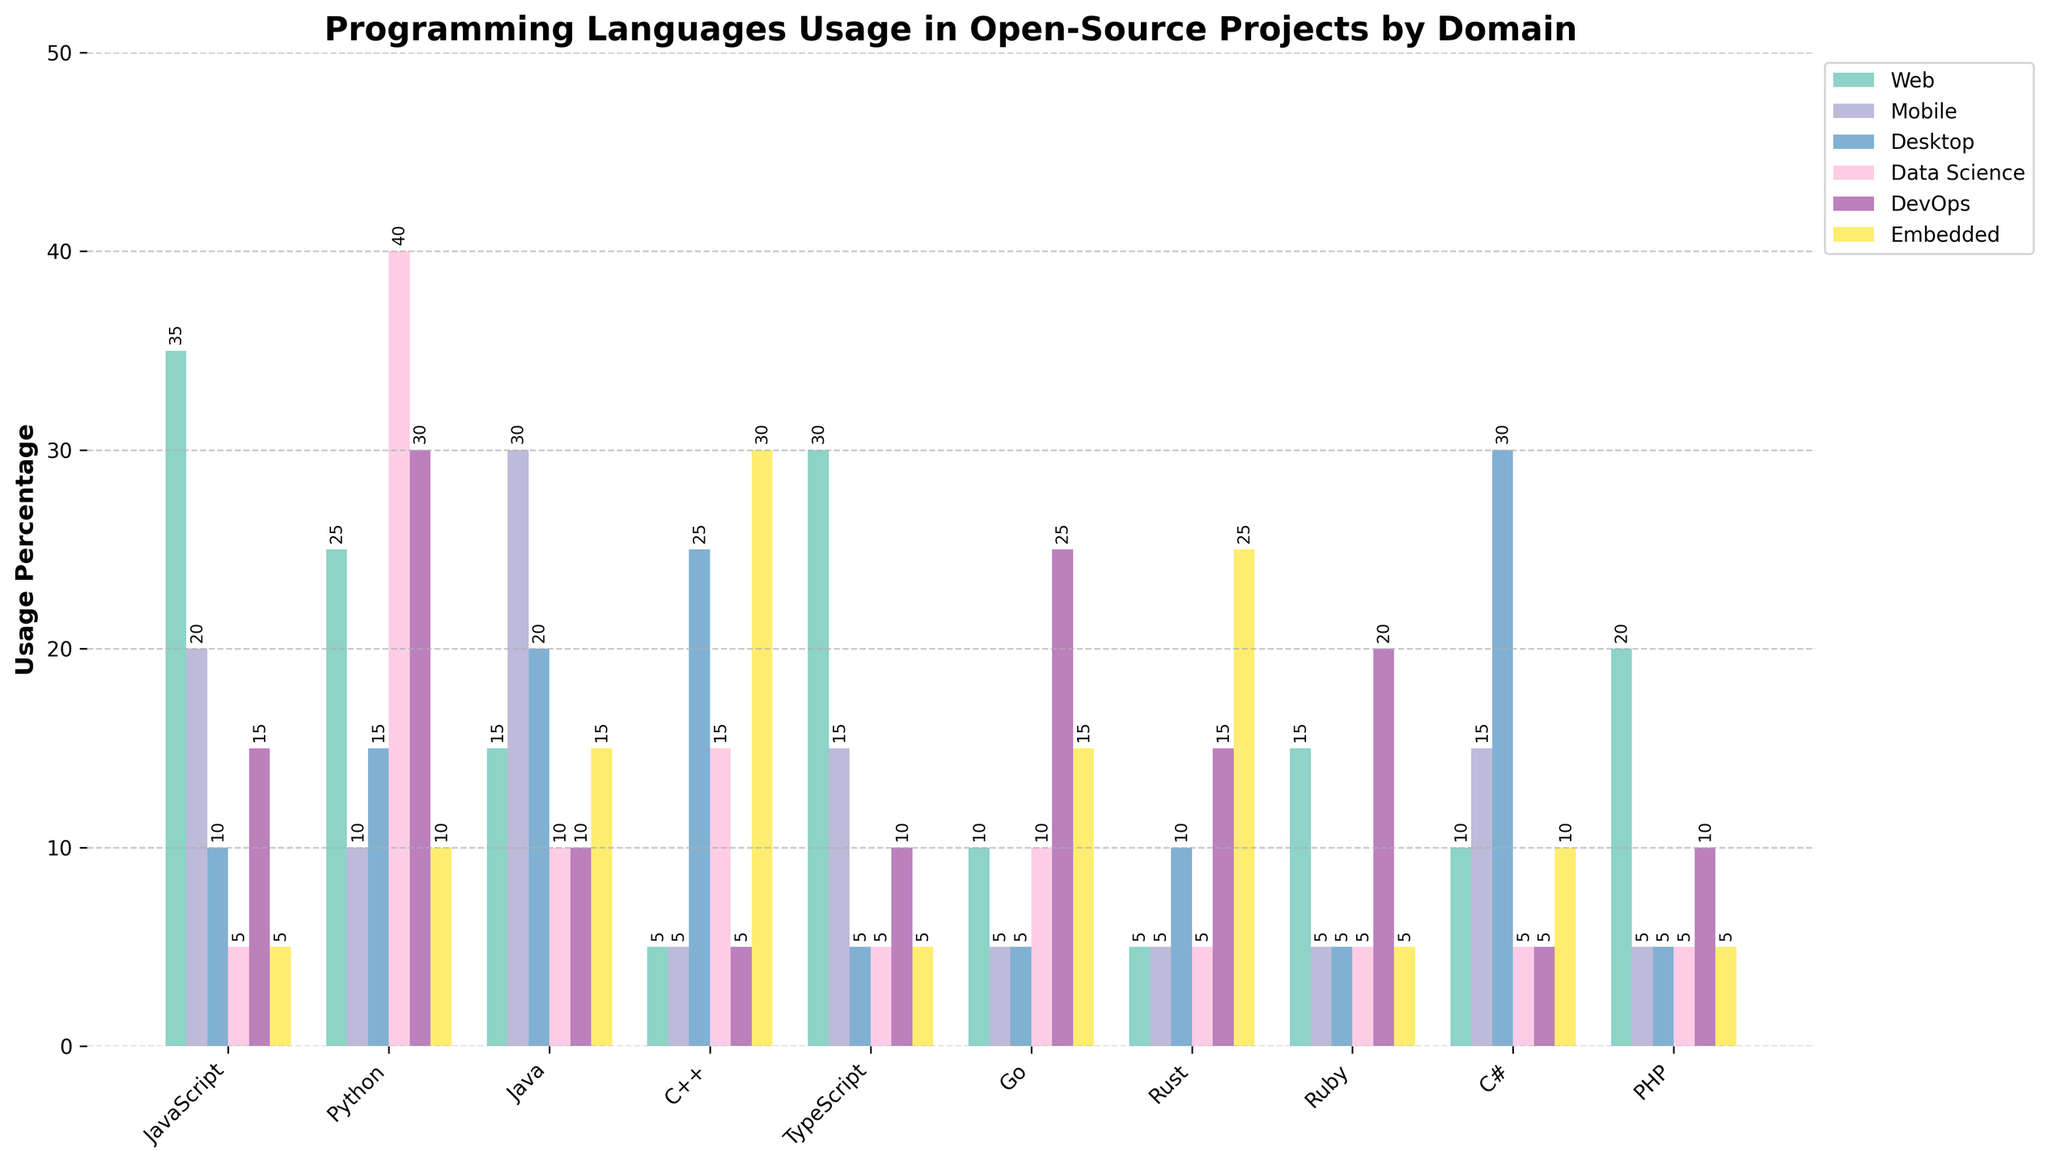What language is most popular for Data Science applications? To determine the most popular language for Data Science, look for the tallest bar in the Data Science category. Python has the tallest bar at 40%.
Answer: Python How much more popular is JavaScript for Web applications compared to PHP? Compare the height of the JavaScript and PHP bars in the Web category. JavaScript's usage is 35%, and PHP's is 20%. The difference is 35% - 20% = 15%.
Answer: 15% What is the total percentage usage of Go across all application domains? Sum the heights of the bars representing Go across all application domains. 10% + 5% + 5% + 10% + 25% + 15% = 70%.
Answer: 70% Which language has the highest usage in Embedded applications? Look for the highest bar in the Embedded category. C++ is the tallest at 30%.
Answer: C++ What is the combined usage percentage of Java and Python in Mobile applications? Add the heights of the Java and Python bars in the Mobile category. Java is at 30%, and Python is at 10%. 30% + 10% = 40%.
Answer: 40% Which two languages have equal popularity in Mobile applications? Observe the bars in the Mobile category to find pairs with equal heights. Rust and C++ both have bars at 5%.
Answer: Rust and C++ Is Ruby more popular for DevOps or Mobile applications? Compare the height of the Ruby bars in the DevOps and Mobile categories. DevOps is at 20%, Mobile is at 5%.
Answer: DevOps Which language is least popular for Web applications? Identify the shortest bar in the Web category. Rust has the shortest bar at 5%.
Answer: Rust How much less popular is C# for Data Science compared to Web applications? Compare the height of the C# bars in Web (10%) and Data Science (5%) categories. The difference is 10% - 5% = 5%.
Answer: 5% What is the average usage of TypeScript across Web, Mobile, and Desktop applications? Sum the heights of TypeScript bars in Web, Mobile, and Desktop, and then divide by 3. (30% + 15% + 5%) / 3 = 50% / 3 ≈ 16.67%.
Answer: 16.67% 